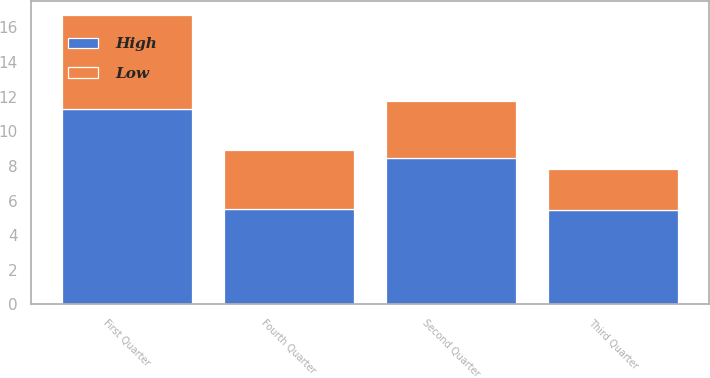Convert chart to OTSL. <chart><loc_0><loc_0><loc_500><loc_500><stacked_bar_chart><ecel><fcel>First Quarter<fcel>Second Quarter<fcel>Third Quarter<fcel>Fourth Quarter<nl><fcel>High<fcel>11.3<fcel>8.48<fcel>5.46<fcel>5.5<nl><fcel>Low<fcel>5.41<fcel>3.25<fcel>2.35<fcel>3.42<nl></chart> 